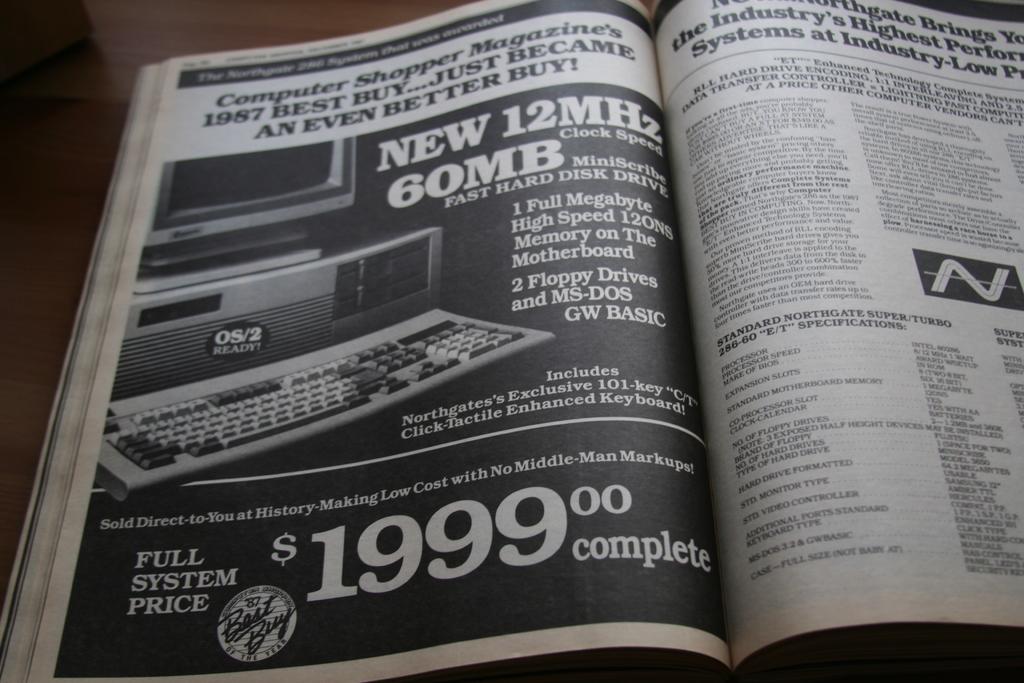How much does the full system cost?
Give a very brief answer. $1999. Whats the amount on the page?
Keep it short and to the point. 1999.00. 